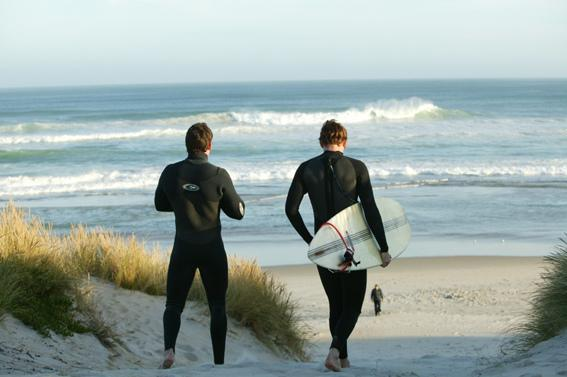Why do they have black suits on?

Choices:
A) disguise
B) stay cool
C) are twins
D) stay warm stay warm 